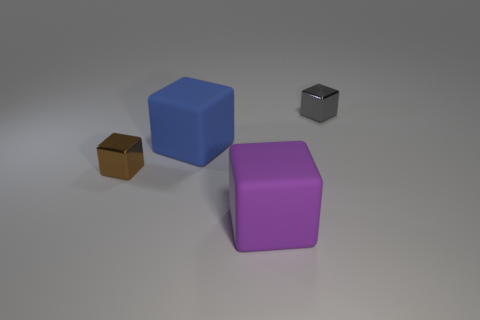There is a tiny cube in front of the tiny gray metallic block; how many blocks are in front of it?
Offer a terse response. 1. Does the small thing that is to the left of the gray block have the same shape as the blue thing?
Your answer should be very brief. Yes. What is the material of the brown object that is the same shape as the tiny gray metallic thing?
Give a very brief answer. Metal. How many things have the same size as the brown cube?
Your answer should be very brief. 1. There is a thing that is behind the tiny brown metallic object and to the right of the large blue rubber cube; what is its color?
Your response must be concise. Gray. Are there fewer yellow rubber cubes than gray metal blocks?
Make the answer very short. Yes. Is the number of gray objects that are to the left of the large blue matte object the same as the number of blue matte objects that are right of the small gray metallic block?
Make the answer very short. Yes. What number of brown things are the same shape as the small gray metallic object?
Offer a very short reply. 1. Are there any large red rubber things?
Keep it short and to the point. No. Does the tiny brown block have the same material as the block behind the blue cube?
Offer a very short reply. Yes. 